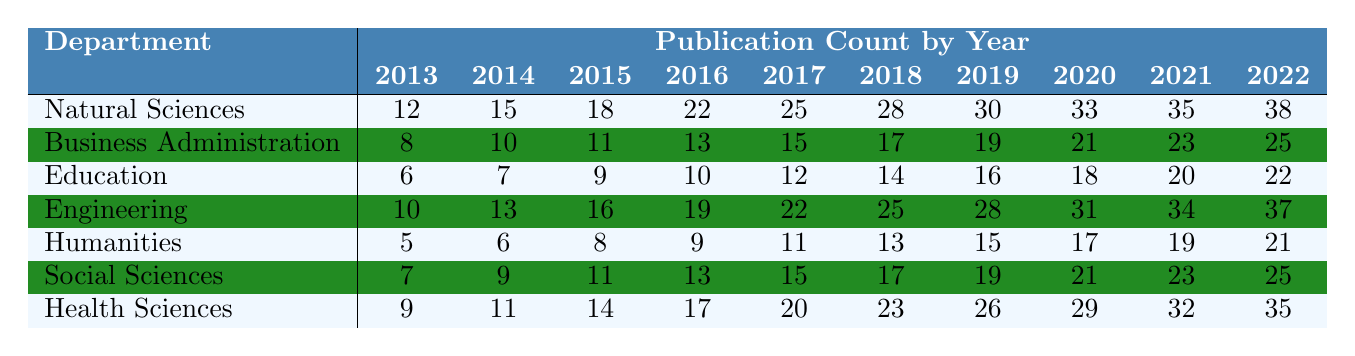What was the publication count for Health Sciences in 2020? The table indicates that the publication count for Health Sciences in 2020 is listed under that department's row for that year. According to the data, the publication count is 29.
Answer: 29 Which department had the highest publication count in 2022? By examining the data for each department in the year 2022, we find that Natural Sciences has a count of 38, Engineering 37, and others lower. Thus, Natural Sciences had the highest publication count in that year.
Answer: Natural Sciences How many publications did the Humanities department have in total over the decade? The total for Humanities can be calculated by adding the publication counts from each year: 5 + 6 + 8 + 9 + 11 + 13 + 15 + 17 + 19 + 21 = 125.
Answer: 125 Did the Social Sciences department consistently increase its publication count each year? By reviewing the data, Social Sciences shows a steady increase for every year from 2013 to 2022, with no decreases in publication count.
Answer: Yes In which year did the Education department have its highest publication count? Looking at the publication counts for the Education department from 2013 to 2022, the highest count is 22 in 2022.
Answer: 2022 What is the average publication count for the Engineering department over the last decade? To find the average, add the publication counts for Engineering (10 + 13 + 16 + 19 + 22 + 25 + 28 + 31 + 34 + 37 = 315) and divide by the number of years (10), which gives 315 / 10 = 31.5.
Answer: 31.5 Which department had the lowest growth in publication count over the decade? By analyzing the growth from 2013 to 2022 for each department, we observe the increases: Natural Sciences (26), Business Administration (17), Education (16), Engineering (27), Humanities (16), Social Sciences (18), and Health Sciences (26). Business Administration had the lowest growth of 17.
Answer: Business Administration What was the total number of publications from all departments in 2015? We find the counts for each department in 2015: 18 (Natural Sciences) + 11 (Business Administration) + 9 (Education) + 16 (Engineering) + 8 (Humanities) + 11 (Social Sciences) + 14 (Health Sciences), which totals 93.
Answer: 93 How many more publications did the Natural Sciences department produce in 2022 compared to 2018? The counts are 38 for 2022 and 28 for 2018. The difference is 38 - 28 = 10 more publications in 2022 compared to 2018.
Answer: 10 Is there any year in which the Health Sciences department had fewer publications than the Humanities department? By comparing each year's counts, we see Health Sciences (9) had fewer than Humanities (5) only in 2013, but in all other years, Health Sciences had a higher count.
Answer: Yes, in 2013 